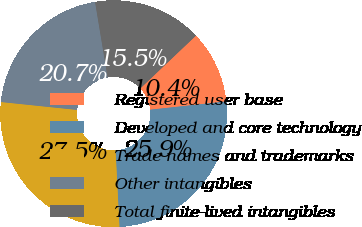<chart> <loc_0><loc_0><loc_500><loc_500><pie_chart><fcel>Registered user base<fcel>Developed and core technology<fcel>Trade names and trademarks<fcel>Other intangibles<fcel>Total finite-lived intangibles<nl><fcel>10.36%<fcel>25.91%<fcel>27.46%<fcel>20.73%<fcel>15.54%<nl></chart> 